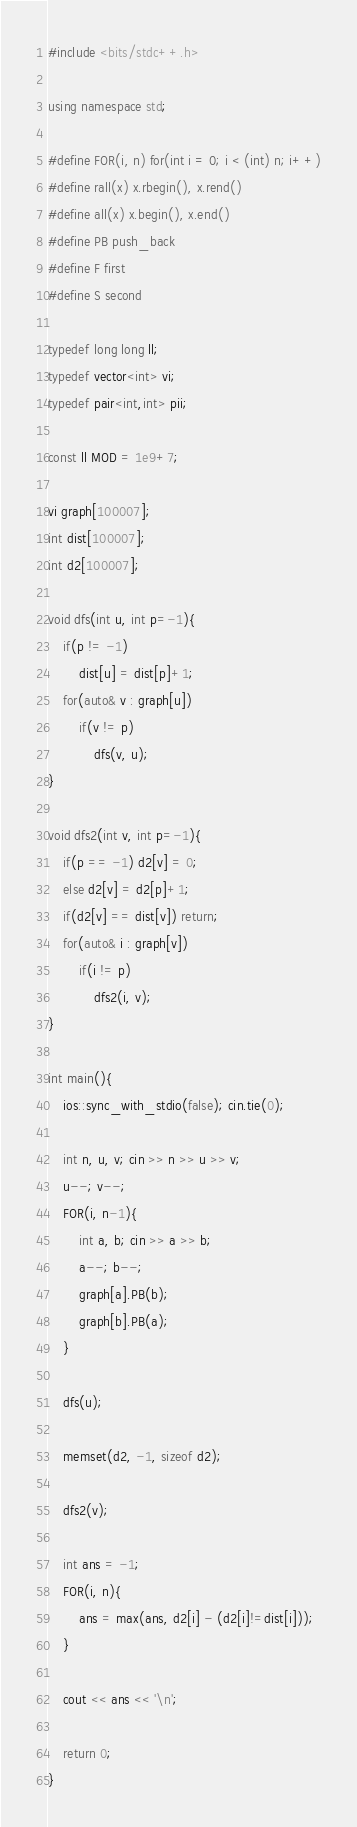<code> <loc_0><loc_0><loc_500><loc_500><_C++_>#include <bits/stdc++.h>

using namespace std;

#define FOR(i, n) for(int i = 0; i < (int) n; i++)
#define rall(x) x.rbegin(), x.rend()
#define all(x) x.begin(), x.end()
#define PB push_back
#define F first
#define S second

typedef long long ll;
typedef vector<int> vi;
typedef pair<int,int> pii;

const ll MOD = 1e9+7;

vi graph[100007];
int dist[100007];
int d2[100007];

void dfs(int u, int p=-1){
	if(p != -1)
		dist[u] = dist[p]+1;
	for(auto& v : graph[u])
		if(v != p)
			dfs(v, u);
}

void dfs2(int v, int p=-1){
	if(p == -1) d2[v] = 0;
	else d2[v] = d2[p]+1;
	if(d2[v] == dist[v]) return;
	for(auto& i : graph[v])
		if(i != p)
			dfs2(i, v);
}

int main(){
	ios::sync_with_stdio(false); cin.tie(0);

	int n, u, v; cin >> n >> u >> v;
	u--; v--;
	FOR(i, n-1){
		int a, b; cin >> a >> b;
		a--; b--;
		graph[a].PB(b);
		graph[b].PB(a);
	}

	dfs(u);

	memset(d2, -1, sizeof d2);

	dfs2(v);

	int ans = -1;
	FOR(i, n){
		ans = max(ans, d2[i] - (d2[i]!=dist[i]));
	}

	cout << ans << '\n';

 	return 0;
}</code> 